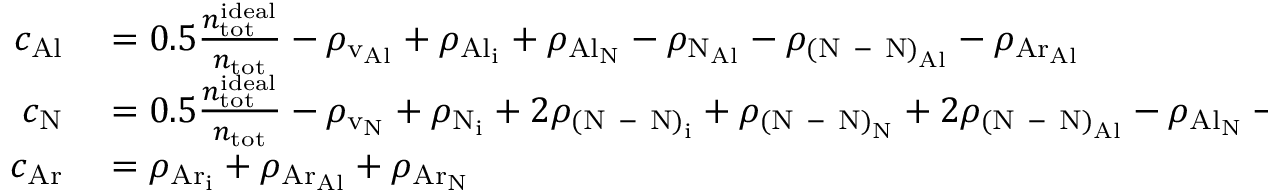Convert formula to latex. <formula><loc_0><loc_0><loc_500><loc_500>\begin{array} { r l } { c _ { A l } } & = 0 . 5 \frac { n _ { t o t } ^ { i d e a l } } { n _ { t o t } } - \rho _ { v _ { A l } } + \rho _ { { A l } _ { i } } + \rho _ { { A l } _ { N } } - \rho _ { { N } _ { A l } } - \rho _ { { ( N \mathrm { - } N ) } _ { A l } } - \rho _ { { A r } _ { A l } } } \\ { c _ { N } } & = 0 . 5 \frac { n _ { t o t } ^ { i d e a l } } { n _ { t o t } } - \rho _ { v _ { N } } + \rho _ { N _ { i } } + 2 \rho _ { { ( N \mathrm { - } N ) } _ { i } } + \rho _ { { ( N \mathrm { - } N ) } _ { N } } + 2 \rho _ { { ( N \mathrm { - } N ) } _ { A l } } - \rho _ { { A l } _ { N } } - \rho _ { { A r } _ { N } } } \\ { c _ { A r } } & = \rho _ { { A r } _ { i } } + \rho _ { { A r } _ { A l } } + \rho _ { { A r } _ { N } } } \end{array}</formula> 